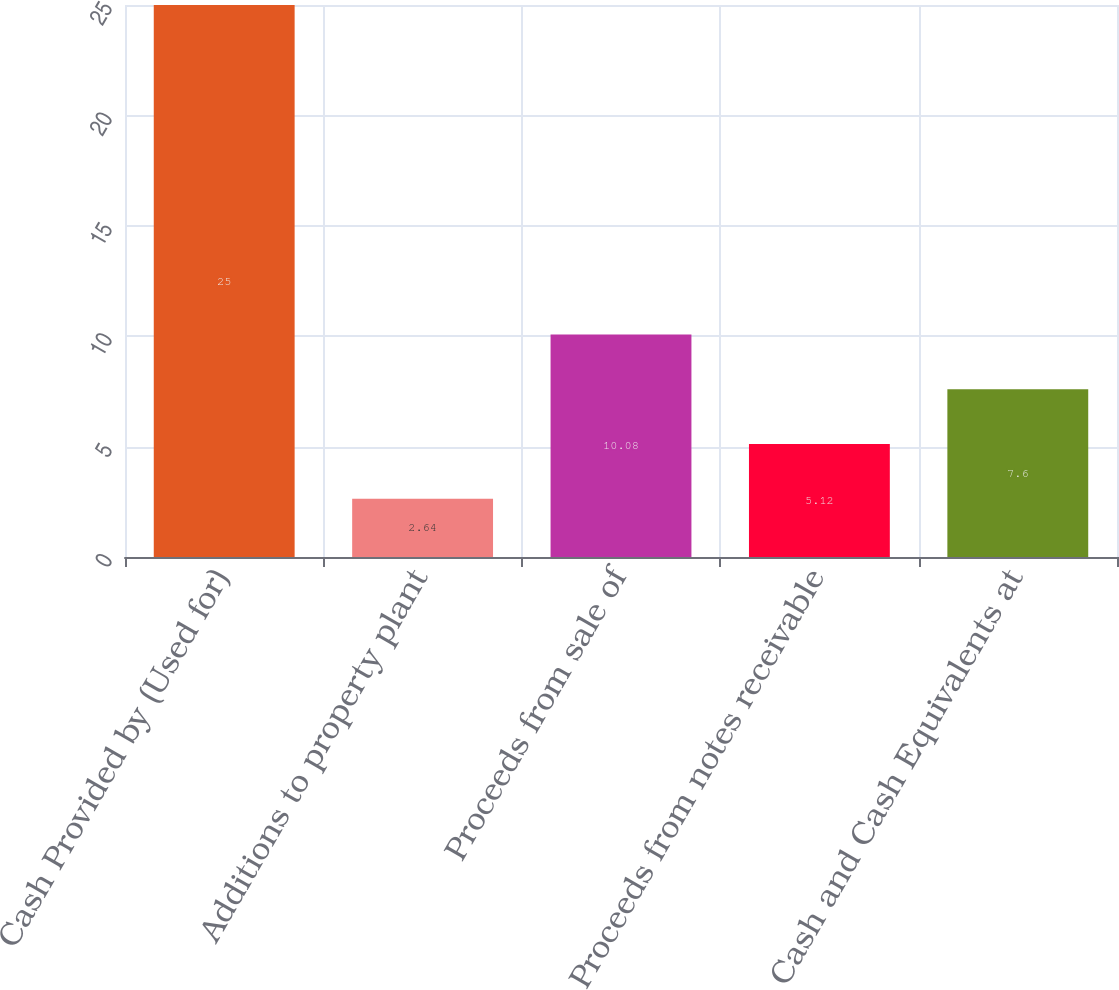Convert chart to OTSL. <chart><loc_0><loc_0><loc_500><loc_500><bar_chart><fcel>Cash Provided by (Used for)<fcel>Additions to property plant<fcel>Proceeds from sale of<fcel>Proceeds from notes receivable<fcel>Cash and Cash Equivalents at<nl><fcel>25<fcel>2.64<fcel>10.08<fcel>5.12<fcel>7.6<nl></chart> 